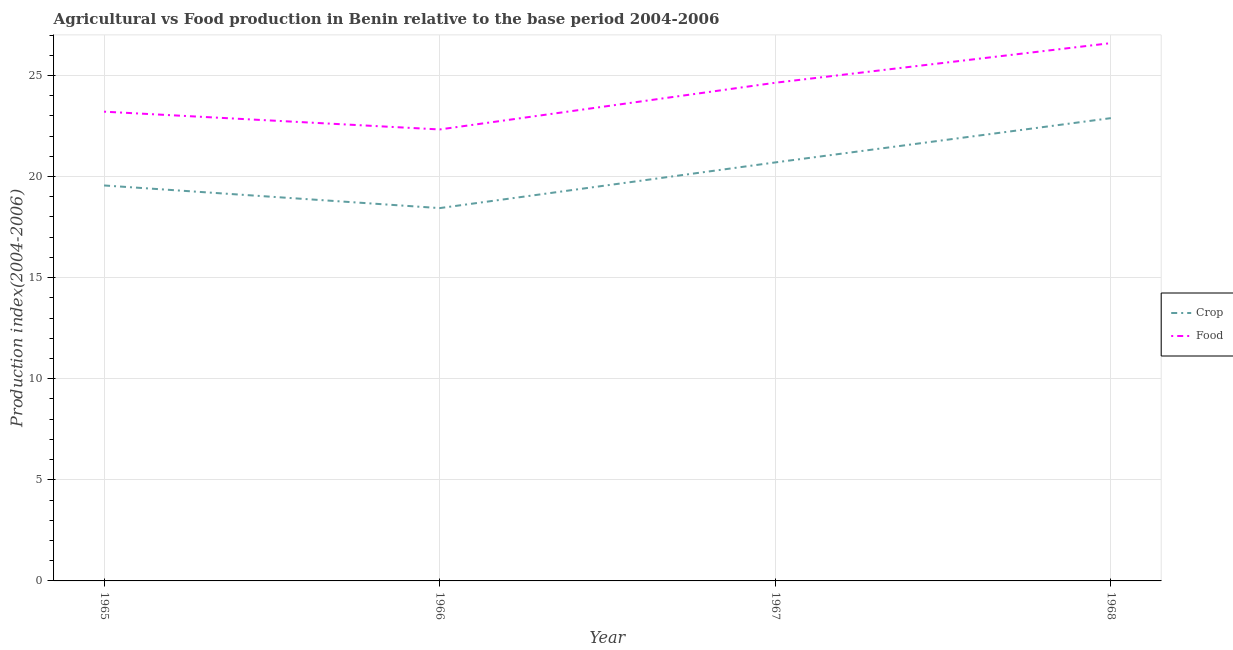Does the line corresponding to food production index intersect with the line corresponding to crop production index?
Offer a very short reply. No. What is the food production index in 1967?
Provide a short and direct response. 24.64. Across all years, what is the maximum crop production index?
Provide a short and direct response. 22.89. Across all years, what is the minimum food production index?
Give a very brief answer. 22.33. In which year was the crop production index maximum?
Your answer should be compact. 1968. In which year was the crop production index minimum?
Make the answer very short. 1966. What is the total food production index in the graph?
Offer a terse response. 96.78. What is the difference between the food production index in 1966 and that in 1968?
Your answer should be compact. -4.27. What is the difference between the crop production index in 1966 and the food production index in 1965?
Offer a very short reply. -4.77. What is the average crop production index per year?
Give a very brief answer. 20.4. In the year 1968, what is the difference between the crop production index and food production index?
Your answer should be very brief. -3.71. In how many years, is the food production index greater than 7?
Offer a terse response. 4. What is the ratio of the crop production index in 1966 to that in 1968?
Ensure brevity in your answer.  0.81. Is the crop production index in 1966 less than that in 1968?
Make the answer very short. Yes. What is the difference between the highest and the second highest crop production index?
Your answer should be very brief. 2.19. What is the difference between the highest and the lowest crop production index?
Ensure brevity in your answer.  4.45. Does the crop production index monotonically increase over the years?
Your answer should be compact. No. Is the crop production index strictly greater than the food production index over the years?
Provide a succinct answer. No. How many lines are there?
Make the answer very short. 2. How many years are there in the graph?
Provide a short and direct response. 4. Does the graph contain any zero values?
Your response must be concise. No. Where does the legend appear in the graph?
Provide a short and direct response. Center right. What is the title of the graph?
Your answer should be very brief. Agricultural vs Food production in Benin relative to the base period 2004-2006. Does "Official creditors" appear as one of the legend labels in the graph?
Give a very brief answer. No. What is the label or title of the X-axis?
Provide a short and direct response. Year. What is the label or title of the Y-axis?
Make the answer very short. Production index(2004-2006). What is the Production index(2004-2006) in Crop in 1965?
Your response must be concise. 19.56. What is the Production index(2004-2006) in Food in 1965?
Your answer should be very brief. 23.21. What is the Production index(2004-2006) in Crop in 1966?
Offer a terse response. 18.44. What is the Production index(2004-2006) of Food in 1966?
Keep it short and to the point. 22.33. What is the Production index(2004-2006) of Crop in 1967?
Your answer should be compact. 20.7. What is the Production index(2004-2006) of Food in 1967?
Your answer should be very brief. 24.64. What is the Production index(2004-2006) in Crop in 1968?
Offer a very short reply. 22.89. What is the Production index(2004-2006) of Food in 1968?
Offer a very short reply. 26.6. Across all years, what is the maximum Production index(2004-2006) in Crop?
Ensure brevity in your answer.  22.89. Across all years, what is the maximum Production index(2004-2006) of Food?
Offer a very short reply. 26.6. Across all years, what is the minimum Production index(2004-2006) of Crop?
Provide a succinct answer. 18.44. Across all years, what is the minimum Production index(2004-2006) in Food?
Make the answer very short. 22.33. What is the total Production index(2004-2006) in Crop in the graph?
Give a very brief answer. 81.59. What is the total Production index(2004-2006) of Food in the graph?
Your answer should be compact. 96.78. What is the difference between the Production index(2004-2006) of Crop in 1965 and that in 1966?
Keep it short and to the point. 1.12. What is the difference between the Production index(2004-2006) of Food in 1965 and that in 1966?
Give a very brief answer. 0.88. What is the difference between the Production index(2004-2006) of Crop in 1965 and that in 1967?
Your answer should be very brief. -1.14. What is the difference between the Production index(2004-2006) in Food in 1965 and that in 1967?
Offer a very short reply. -1.43. What is the difference between the Production index(2004-2006) in Crop in 1965 and that in 1968?
Provide a succinct answer. -3.33. What is the difference between the Production index(2004-2006) of Food in 1965 and that in 1968?
Provide a succinct answer. -3.39. What is the difference between the Production index(2004-2006) of Crop in 1966 and that in 1967?
Make the answer very short. -2.26. What is the difference between the Production index(2004-2006) in Food in 1966 and that in 1967?
Your answer should be compact. -2.31. What is the difference between the Production index(2004-2006) of Crop in 1966 and that in 1968?
Provide a short and direct response. -4.45. What is the difference between the Production index(2004-2006) in Food in 1966 and that in 1968?
Make the answer very short. -4.27. What is the difference between the Production index(2004-2006) in Crop in 1967 and that in 1968?
Ensure brevity in your answer.  -2.19. What is the difference between the Production index(2004-2006) in Food in 1967 and that in 1968?
Offer a terse response. -1.96. What is the difference between the Production index(2004-2006) of Crop in 1965 and the Production index(2004-2006) of Food in 1966?
Keep it short and to the point. -2.77. What is the difference between the Production index(2004-2006) in Crop in 1965 and the Production index(2004-2006) in Food in 1967?
Your response must be concise. -5.08. What is the difference between the Production index(2004-2006) in Crop in 1965 and the Production index(2004-2006) in Food in 1968?
Give a very brief answer. -7.04. What is the difference between the Production index(2004-2006) in Crop in 1966 and the Production index(2004-2006) in Food in 1968?
Provide a short and direct response. -8.16. What is the average Production index(2004-2006) in Crop per year?
Offer a terse response. 20.4. What is the average Production index(2004-2006) in Food per year?
Ensure brevity in your answer.  24.2. In the year 1965, what is the difference between the Production index(2004-2006) in Crop and Production index(2004-2006) in Food?
Your answer should be compact. -3.65. In the year 1966, what is the difference between the Production index(2004-2006) of Crop and Production index(2004-2006) of Food?
Your response must be concise. -3.89. In the year 1967, what is the difference between the Production index(2004-2006) in Crop and Production index(2004-2006) in Food?
Provide a short and direct response. -3.94. In the year 1968, what is the difference between the Production index(2004-2006) in Crop and Production index(2004-2006) in Food?
Your answer should be compact. -3.71. What is the ratio of the Production index(2004-2006) in Crop in 1965 to that in 1966?
Offer a very short reply. 1.06. What is the ratio of the Production index(2004-2006) in Food in 1965 to that in 1966?
Your answer should be very brief. 1.04. What is the ratio of the Production index(2004-2006) in Crop in 1965 to that in 1967?
Give a very brief answer. 0.94. What is the ratio of the Production index(2004-2006) in Food in 1965 to that in 1967?
Provide a short and direct response. 0.94. What is the ratio of the Production index(2004-2006) of Crop in 1965 to that in 1968?
Keep it short and to the point. 0.85. What is the ratio of the Production index(2004-2006) in Food in 1965 to that in 1968?
Provide a short and direct response. 0.87. What is the ratio of the Production index(2004-2006) of Crop in 1966 to that in 1967?
Offer a terse response. 0.89. What is the ratio of the Production index(2004-2006) of Food in 1966 to that in 1967?
Offer a very short reply. 0.91. What is the ratio of the Production index(2004-2006) of Crop in 1966 to that in 1968?
Give a very brief answer. 0.81. What is the ratio of the Production index(2004-2006) of Food in 1966 to that in 1968?
Ensure brevity in your answer.  0.84. What is the ratio of the Production index(2004-2006) of Crop in 1967 to that in 1968?
Offer a terse response. 0.9. What is the ratio of the Production index(2004-2006) in Food in 1967 to that in 1968?
Make the answer very short. 0.93. What is the difference between the highest and the second highest Production index(2004-2006) of Crop?
Offer a very short reply. 2.19. What is the difference between the highest and the second highest Production index(2004-2006) of Food?
Keep it short and to the point. 1.96. What is the difference between the highest and the lowest Production index(2004-2006) in Crop?
Offer a very short reply. 4.45. What is the difference between the highest and the lowest Production index(2004-2006) in Food?
Ensure brevity in your answer.  4.27. 